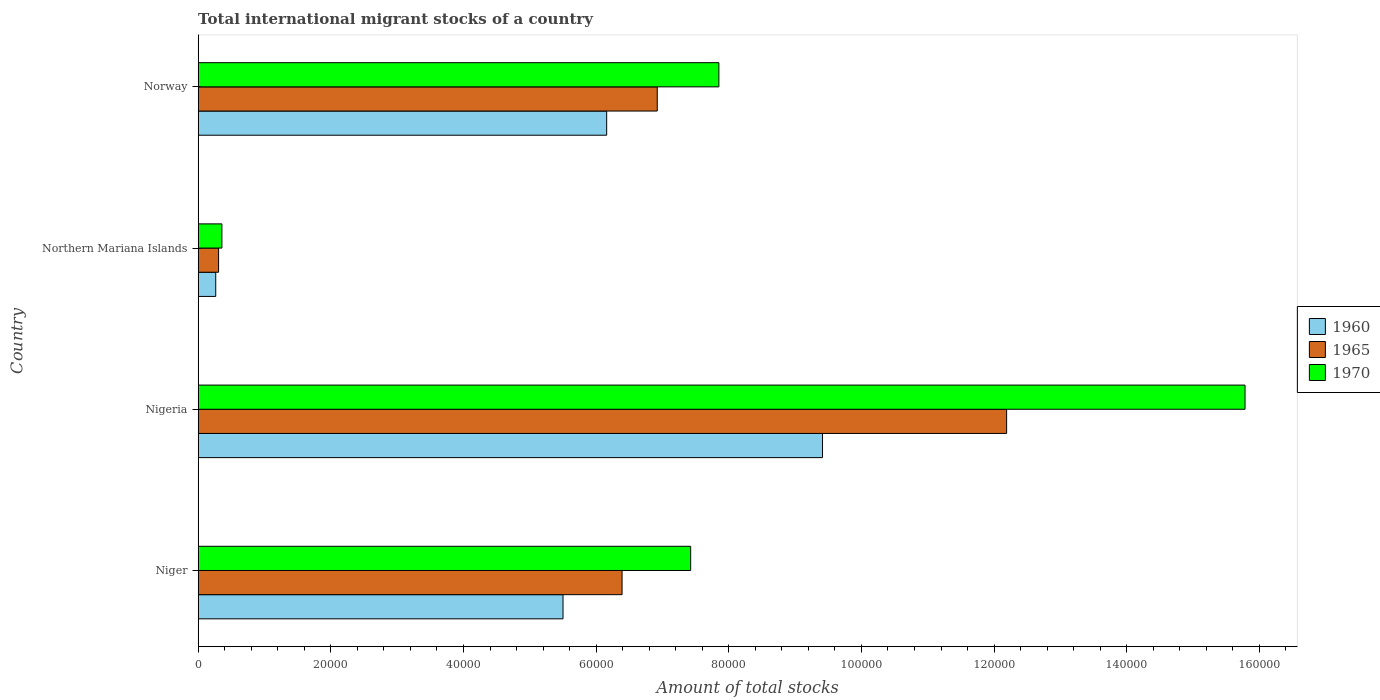Are the number of bars per tick equal to the number of legend labels?
Offer a terse response. Yes. How many bars are there on the 2nd tick from the top?
Provide a short and direct response. 3. What is the label of the 2nd group of bars from the top?
Give a very brief answer. Northern Mariana Islands. What is the amount of total stocks in in 1970 in Norway?
Provide a short and direct response. 7.85e+04. Across all countries, what is the maximum amount of total stocks in in 1965?
Your answer should be very brief. 1.22e+05. Across all countries, what is the minimum amount of total stocks in in 1960?
Provide a succinct answer. 2648. In which country was the amount of total stocks in in 1960 maximum?
Give a very brief answer. Nigeria. In which country was the amount of total stocks in in 1965 minimum?
Provide a short and direct response. Northern Mariana Islands. What is the total amount of total stocks in in 1960 in the graph?
Offer a terse response. 2.13e+05. What is the difference between the amount of total stocks in in 1965 in Nigeria and that in Norway?
Keep it short and to the point. 5.27e+04. What is the difference between the amount of total stocks in in 1965 in Norway and the amount of total stocks in in 1970 in Nigeria?
Your answer should be compact. -8.86e+04. What is the average amount of total stocks in in 1970 per country?
Offer a very short reply. 7.85e+04. What is the difference between the amount of total stocks in in 1970 and amount of total stocks in in 1965 in Norway?
Your response must be concise. 9291. What is the ratio of the amount of total stocks in in 1970 in Niger to that in Norway?
Your answer should be compact. 0.95. Is the amount of total stocks in in 1970 in Niger less than that in Northern Mariana Islands?
Give a very brief answer. No. What is the difference between the highest and the second highest amount of total stocks in in 1965?
Keep it short and to the point. 5.27e+04. What is the difference between the highest and the lowest amount of total stocks in in 1965?
Keep it short and to the point. 1.19e+05. In how many countries, is the amount of total stocks in in 1970 greater than the average amount of total stocks in in 1970 taken over all countries?
Ensure brevity in your answer.  1. Is the sum of the amount of total stocks in in 1960 in Northern Mariana Islands and Norway greater than the maximum amount of total stocks in in 1965 across all countries?
Provide a short and direct response. No. What does the 1st bar from the top in Northern Mariana Islands represents?
Your response must be concise. 1970. What does the 3rd bar from the bottom in Niger represents?
Keep it short and to the point. 1970. How many bars are there?
Offer a terse response. 12. How many countries are there in the graph?
Provide a short and direct response. 4. Are the values on the major ticks of X-axis written in scientific E-notation?
Provide a succinct answer. No. Does the graph contain any zero values?
Offer a terse response. No. Does the graph contain grids?
Provide a succinct answer. No. How many legend labels are there?
Your answer should be compact. 3. How are the legend labels stacked?
Make the answer very short. Vertical. What is the title of the graph?
Offer a very short reply. Total international migrant stocks of a country. Does "1977" appear as one of the legend labels in the graph?
Make the answer very short. No. What is the label or title of the X-axis?
Your answer should be compact. Amount of total stocks. What is the label or title of the Y-axis?
Provide a succinct answer. Country. What is the Amount of total stocks of 1960 in Niger?
Offer a terse response. 5.50e+04. What is the Amount of total stocks in 1965 in Niger?
Make the answer very short. 6.39e+04. What is the Amount of total stocks of 1970 in Niger?
Provide a short and direct response. 7.43e+04. What is the Amount of total stocks in 1960 in Nigeria?
Provide a short and direct response. 9.41e+04. What is the Amount of total stocks of 1965 in Nigeria?
Ensure brevity in your answer.  1.22e+05. What is the Amount of total stocks of 1970 in Nigeria?
Offer a very short reply. 1.58e+05. What is the Amount of total stocks in 1960 in Northern Mariana Islands?
Your answer should be compact. 2648. What is the Amount of total stocks of 1965 in Northern Mariana Islands?
Give a very brief answer. 3077. What is the Amount of total stocks in 1970 in Northern Mariana Islands?
Provide a succinct answer. 3576. What is the Amount of total stocks of 1960 in Norway?
Provide a succinct answer. 6.16e+04. What is the Amount of total stocks of 1965 in Norway?
Your response must be concise. 6.92e+04. What is the Amount of total stocks of 1970 in Norway?
Keep it short and to the point. 7.85e+04. Across all countries, what is the maximum Amount of total stocks in 1960?
Provide a short and direct response. 9.41e+04. Across all countries, what is the maximum Amount of total stocks in 1965?
Give a very brief answer. 1.22e+05. Across all countries, what is the maximum Amount of total stocks of 1970?
Your response must be concise. 1.58e+05. Across all countries, what is the minimum Amount of total stocks in 1960?
Your answer should be compact. 2648. Across all countries, what is the minimum Amount of total stocks in 1965?
Your answer should be compact. 3077. Across all countries, what is the minimum Amount of total stocks of 1970?
Provide a short and direct response. 3576. What is the total Amount of total stocks of 1960 in the graph?
Your response must be concise. 2.13e+05. What is the total Amount of total stocks of 1965 in the graph?
Your answer should be compact. 2.58e+05. What is the total Amount of total stocks of 1970 in the graph?
Offer a terse response. 3.14e+05. What is the difference between the Amount of total stocks in 1960 in Niger and that in Nigeria?
Provide a succinct answer. -3.91e+04. What is the difference between the Amount of total stocks of 1965 in Niger and that in Nigeria?
Offer a terse response. -5.80e+04. What is the difference between the Amount of total stocks in 1970 in Niger and that in Nigeria?
Your answer should be very brief. -8.36e+04. What is the difference between the Amount of total stocks in 1960 in Niger and that in Northern Mariana Islands?
Your answer should be very brief. 5.24e+04. What is the difference between the Amount of total stocks in 1965 in Niger and that in Northern Mariana Islands?
Your answer should be compact. 6.08e+04. What is the difference between the Amount of total stocks of 1970 in Niger and that in Northern Mariana Islands?
Your answer should be compact. 7.07e+04. What is the difference between the Amount of total stocks of 1960 in Niger and that in Norway?
Provide a short and direct response. -6583. What is the difference between the Amount of total stocks of 1965 in Niger and that in Norway?
Make the answer very short. -5305. What is the difference between the Amount of total stocks of 1970 in Niger and that in Norway?
Ensure brevity in your answer.  -4253. What is the difference between the Amount of total stocks in 1960 in Nigeria and that in Northern Mariana Islands?
Your response must be concise. 9.15e+04. What is the difference between the Amount of total stocks of 1965 in Nigeria and that in Northern Mariana Islands?
Give a very brief answer. 1.19e+05. What is the difference between the Amount of total stocks of 1970 in Nigeria and that in Northern Mariana Islands?
Give a very brief answer. 1.54e+05. What is the difference between the Amount of total stocks of 1960 in Nigeria and that in Norway?
Offer a very short reply. 3.25e+04. What is the difference between the Amount of total stocks in 1965 in Nigeria and that in Norway?
Your answer should be compact. 5.27e+04. What is the difference between the Amount of total stocks of 1970 in Nigeria and that in Norway?
Keep it short and to the point. 7.93e+04. What is the difference between the Amount of total stocks of 1960 in Northern Mariana Islands and that in Norway?
Offer a terse response. -5.89e+04. What is the difference between the Amount of total stocks in 1965 in Northern Mariana Islands and that in Norway?
Keep it short and to the point. -6.61e+04. What is the difference between the Amount of total stocks of 1970 in Northern Mariana Islands and that in Norway?
Your response must be concise. -7.49e+04. What is the difference between the Amount of total stocks in 1960 in Niger and the Amount of total stocks in 1965 in Nigeria?
Provide a succinct answer. -6.69e+04. What is the difference between the Amount of total stocks of 1960 in Niger and the Amount of total stocks of 1970 in Nigeria?
Make the answer very short. -1.03e+05. What is the difference between the Amount of total stocks of 1965 in Niger and the Amount of total stocks of 1970 in Nigeria?
Provide a succinct answer. -9.39e+04. What is the difference between the Amount of total stocks in 1960 in Niger and the Amount of total stocks in 1965 in Northern Mariana Islands?
Offer a terse response. 5.19e+04. What is the difference between the Amount of total stocks of 1960 in Niger and the Amount of total stocks of 1970 in Northern Mariana Islands?
Offer a terse response. 5.14e+04. What is the difference between the Amount of total stocks of 1965 in Niger and the Amount of total stocks of 1970 in Northern Mariana Islands?
Ensure brevity in your answer.  6.03e+04. What is the difference between the Amount of total stocks in 1960 in Niger and the Amount of total stocks in 1965 in Norway?
Your response must be concise. -1.42e+04. What is the difference between the Amount of total stocks of 1960 in Niger and the Amount of total stocks of 1970 in Norway?
Your answer should be very brief. -2.35e+04. What is the difference between the Amount of total stocks in 1965 in Niger and the Amount of total stocks in 1970 in Norway?
Offer a very short reply. -1.46e+04. What is the difference between the Amount of total stocks of 1960 in Nigeria and the Amount of total stocks of 1965 in Northern Mariana Islands?
Offer a very short reply. 9.11e+04. What is the difference between the Amount of total stocks of 1960 in Nigeria and the Amount of total stocks of 1970 in Northern Mariana Islands?
Provide a succinct answer. 9.06e+04. What is the difference between the Amount of total stocks of 1965 in Nigeria and the Amount of total stocks of 1970 in Northern Mariana Islands?
Provide a succinct answer. 1.18e+05. What is the difference between the Amount of total stocks in 1960 in Nigeria and the Amount of total stocks in 1965 in Norway?
Offer a terse response. 2.49e+04. What is the difference between the Amount of total stocks of 1960 in Nigeria and the Amount of total stocks of 1970 in Norway?
Offer a terse response. 1.56e+04. What is the difference between the Amount of total stocks in 1965 in Nigeria and the Amount of total stocks in 1970 in Norway?
Your response must be concise. 4.34e+04. What is the difference between the Amount of total stocks in 1960 in Northern Mariana Islands and the Amount of total stocks in 1965 in Norway?
Give a very brief answer. -6.66e+04. What is the difference between the Amount of total stocks of 1960 in Northern Mariana Islands and the Amount of total stocks of 1970 in Norway?
Offer a very short reply. -7.59e+04. What is the difference between the Amount of total stocks of 1965 in Northern Mariana Islands and the Amount of total stocks of 1970 in Norway?
Ensure brevity in your answer.  -7.54e+04. What is the average Amount of total stocks in 1960 per country?
Your response must be concise. 5.33e+04. What is the average Amount of total stocks in 1965 per country?
Make the answer very short. 6.45e+04. What is the average Amount of total stocks in 1970 per country?
Your response must be concise. 7.85e+04. What is the difference between the Amount of total stocks in 1960 and Amount of total stocks in 1965 in Niger?
Offer a very short reply. -8903. What is the difference between the Amount of total stocks of 1960 and Amount of total stocks of 1970 in Niger?
Make the answer very short. -1.92e+04. What is the difference between the Amount of total stocks in 1965 and Amount of total stocks in 1970 in Niger?
Your response must be concise. -1.03e+04. What is the difference between the Amount of total stocks in 1960 and Amount of total stocks in 1965 in Nigeria?
Offer a very short reply. -2.78e+04. What is the difference between the Amount of total stocks of 1960 and Amount of total stocks of 1970 in Nigeria?
Offer a very short reply. -6.37e+04. What is the difference between the Amount of total stocks of 1965 and Amount of total stocks of 1970 in Nigeria?
Give a very brief answer. -3.59e+04. What is the difference between the Amount of total stocks in 1960 and Amount of total stocks in 1965 in Northern Mariana Islands?
Give a very brief answer. -429. What is the difference between the Amount of total stocks in 1960 and Amount of total stocks in 1970 in Northern Mariana Islands?
Offer a very short reply. -928. What is the difference between the Amount of total stocks of 1965 and Amount of total stocks of 1970 in Northern Mariana Islands?
Offer a terse response. -499. What is the difference between the Amount of total stocks of 1960 and Amount of total stocks of 1965 in Norway?
Your answer should be compact. -7625. What is the difference between the Amount of total stocks in 1960 and Amount of total stocks in 1970 in Norway?
Your answer should be compact. -1.69e+04. What is the difference between the Amount of total stocks of 1965 and Amount of total stocks of 1970 in Norway?
Provide a succinct answer. -9291. What is the ratio of the Amount of total stocks of 1960 in Niger to that in Nigeria?
Your answer should be very brief. 0.58. What is the ratio of the Amount of total stocks of 1965 in Niger to that in Nigeria?
Provide a short and direct response. 0.52. What is the ratio of the Amount of total stocks in 1970 in Niger to that in Nigeria?
Provide a short and direct response. 0.47. What is the ratio of the Amount of total stocks in 1960 in Niger to that in Northern Mariana Islands?
Make the answer very short. 20.77. What is the ratio of the Amount of total stocks of 1965 in Niger to that in Northern Mariana Islands?
Make the answer very short. 20.77. What is the ratio of the Amount of total stocks in 1970 in Niger to that in Northern Mariana Islands?
Ensure brevity in your answer.  20.76. What is the ratio of the Amount of total stocks of 1960 in Niger to that in Norway?
Offer a terse response. 0.89. What is the ratio of the Amount of total stocks of 1965 in Niger to that in Norway?
Keep it short and to the point. 0.92. What is the ratio of the Amount of total stocks in 1970 in Niger to that in Norway?
Keep it short and to the point. 0.95. What is the ratio of the Amount of total stocks in 1960 in Nigeria to that in Northern Mariana Islands?
Keep it short and to the point. 35.55. What is the ratio of the Amount of total stocks of 1965 in Nigeria to that in Northern Mariana Islands?
Give a very brief answer. 39.61. What is the ratio of the Amount of total stocks of 1970 in Nigeria to that in Northern Mariana Islands?
Provide a short and direct response. 44.14. What is the ratio of the Amount of total stocks in 1960 in Nigeria to that in Norway?
Provide a short and direct response. 1.53. What is the ratio of the Amount of total stocks in 1965 in Nigeria to that in Norway?
Provide a short and direct response. 1.76. What is the ratio of the Amount of total stocks in 1970 in Nigeria to that in Norway?
Your answer should be very brief. 2.01. What is the ratio of the Amount of total stocks of 1960 in Northern Mariana Islands to that in Norway?
Make the answer very short. 0.04. What is the ratio of the Amount of total stocks of 1965 in Northern Mariana Islands to that in Norway?
Your answer should be compact. 0.04. What is the ratio of the Amount of total stocks in 1970 in Northern Mariana Islands to that in Norway?
Make the answer very short. 0.05. What is the difference between the highest and the second highest Amount of total stocks in 1960?
Your answer should be compact. 3.25e+04. What is the difference between the highest and the second highest Amount of total stocks in 1965?
Make the answer very short. 5.27e+04. What is the difference between the highest and the second highest Amount of total stocks in 1970?
Ensure brevity in your answer.  7.93e+04. What is the difference between the highest and the lowest Amount of total stocks of 1960?
Give a very brief answer. 9.15e+04. What is the difference between the highest and the lowest Amount of total stocks in 1965?
Provide a succinct answer. 1.19e+05. What is the difference between the highest and the lowest Amount of total stocks in 1970?
Ensure brevity in your answer.  1.54e+05. 